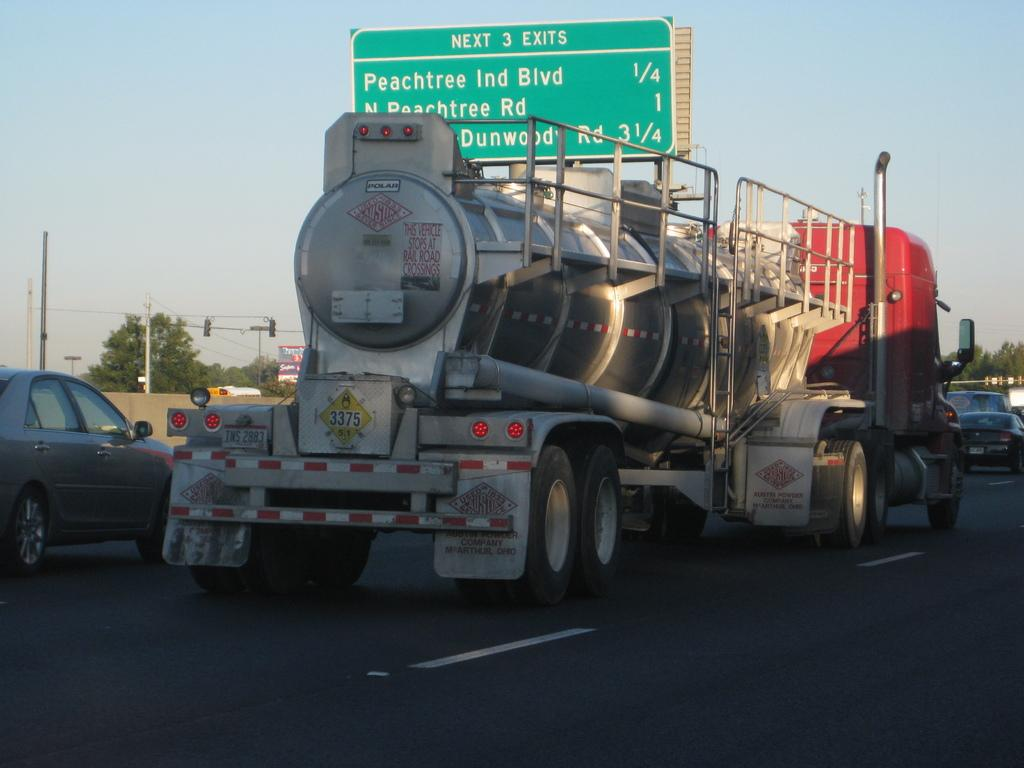What can be seen on the road in the image? There are vehicles on the road in the image. What is visible in the background of the image? In the background of the image, there is a wall, trees, poles, a traffic signal, a banner, a board, and the sky. Can you describe the traffic signal in the image? The traffic signal is located in the background of the image. What type of structure is present on the wall in the image? The provided facts do not mention any specific structure on the wall. What type of copper material is used to make the pancakes in the image? There are no pancakes present in the image, and copper is not mentioned as a material used in the image. How many cakes are stacked on top of each other in the image? There are no cakes present in the image. 